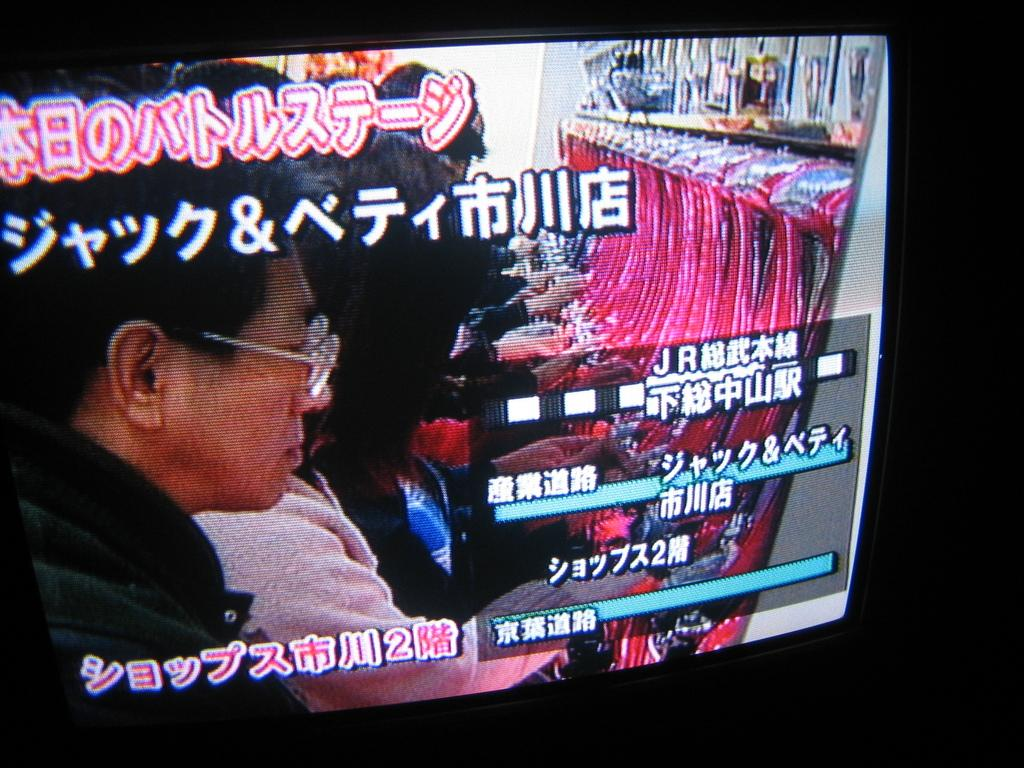What can be seen on the screen in the image? There are people, things, and writing visible on the screen. Can you describe the people on the screen? Unfortunately, the provided facts do not give enough information to describe the people on the screen. What types of things can be seen on the screen? The provided facts do not specify the types of things visible on the screen. Where is the hen located on the screen? There is no hen present on the screen in the image. What color is the brain visible on the screen? There is no brain present on the screen in the image. 